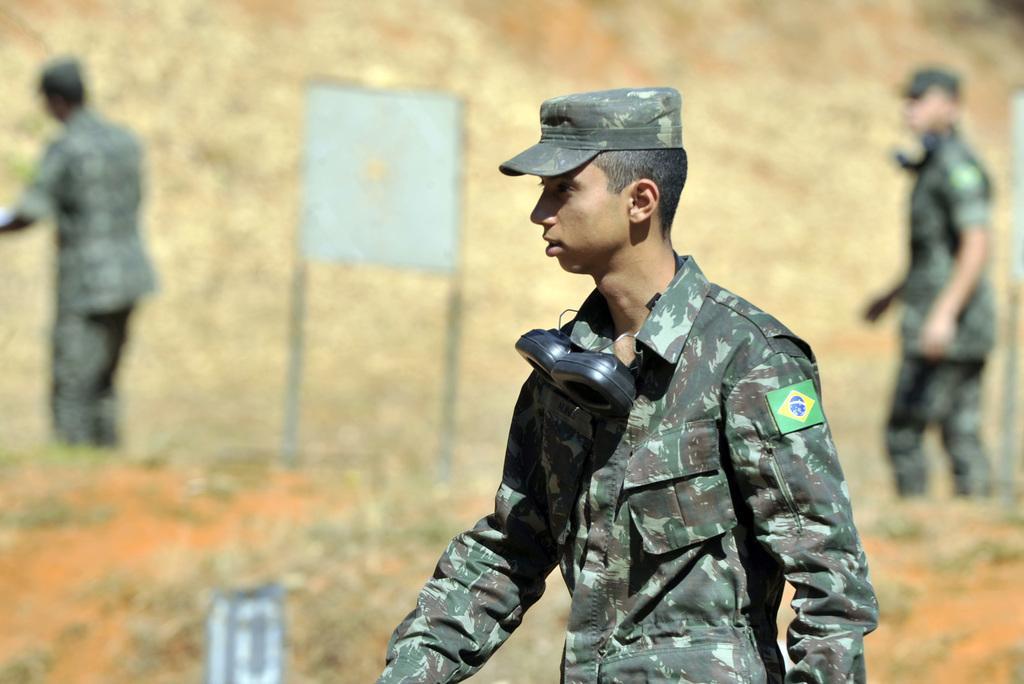Could you give a brief overview of what you see in this image? As we can see in the image there are three people wearing army dress and there is a sign board over here. The image is little blurry. 